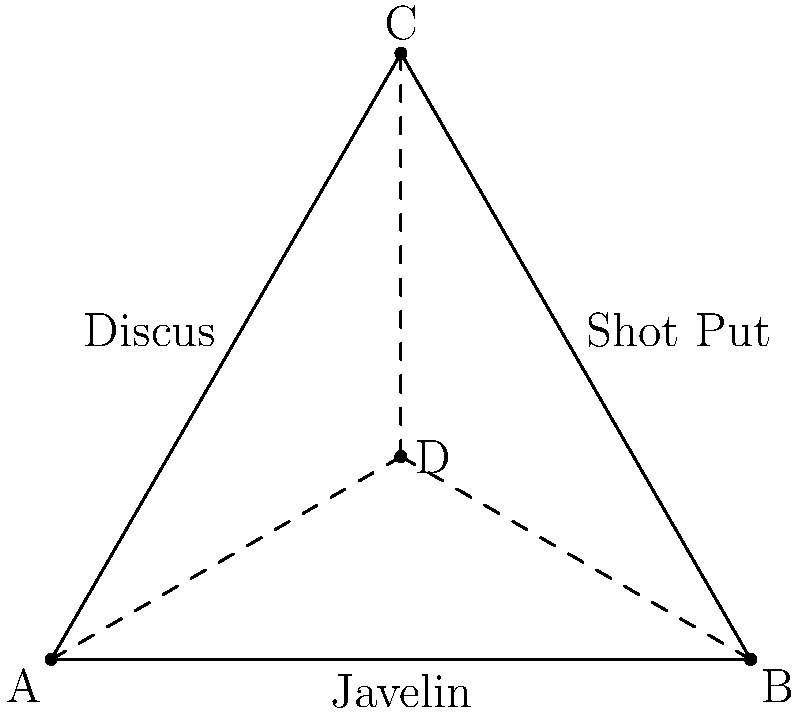Consider a group $G$ representing the symmetries of an equilateral triangle formed by arranging three different track and field throwing equipment: a javelin, a discus, and a shot put. Let $H$ be the subgroup of rotations of this triangle. Determine the order of the quotient group $G/H$ and explain its significance in terms of the equipment arrangement. Let's approach this step-by-step:

1) First, we need to identify the elements of group $G$:
   - 3 rotations (including the identity)
   - 3 reflections (one across each altitude)
   So, $|G| = 6$

2) The subgroup $H$ consists of rotations:
   - Identity (0°)
   - 120° clockwise
   - 240° clockwise (or 120° counterclockwise)
   So, $|H| = 3$

3) The Lagrange theorem states that for a subgroup $H$ of a finite group $G$:
   $|G| = |H| \cdot [G:H]$
   where $[G:H]$ is the index of $H$ in $G$, which is equal to the order of the quotient group $G/H$.

4) Therefore:
   $|G/H| = |G| / |H| = 6 / 3 = 2$

5) The quotient group $G/H$ has order 2, which means it has two cosets:
   - The coset of rotations (identity coset)
   - The coset of reflections

6) In terms of the equipment arrangement:
   - The identity coset represents maintaining the original orientation of the equipment.
   - The reflection coset represents flipping the arrangement, which swaps the positions of two pieces of equipment while keeping one in place.

This result showcases the fundamental symmetry in the arrangement: there are two distinct ways to view the triangle - either in its original orientation or as its mirror image.
Answer: $|G/H| = 2$ 